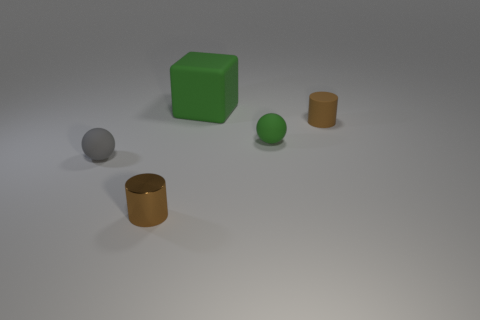Could you describe the lighting in the scene? The lighting in the scene is soft and diffuse, coming from the upper right side. It casts gentle shadows on the left side of the objects, suggesting an evenly spread light source that's not too harsh, likely to simulate an overcast day or a room with soft ambient lighting. 